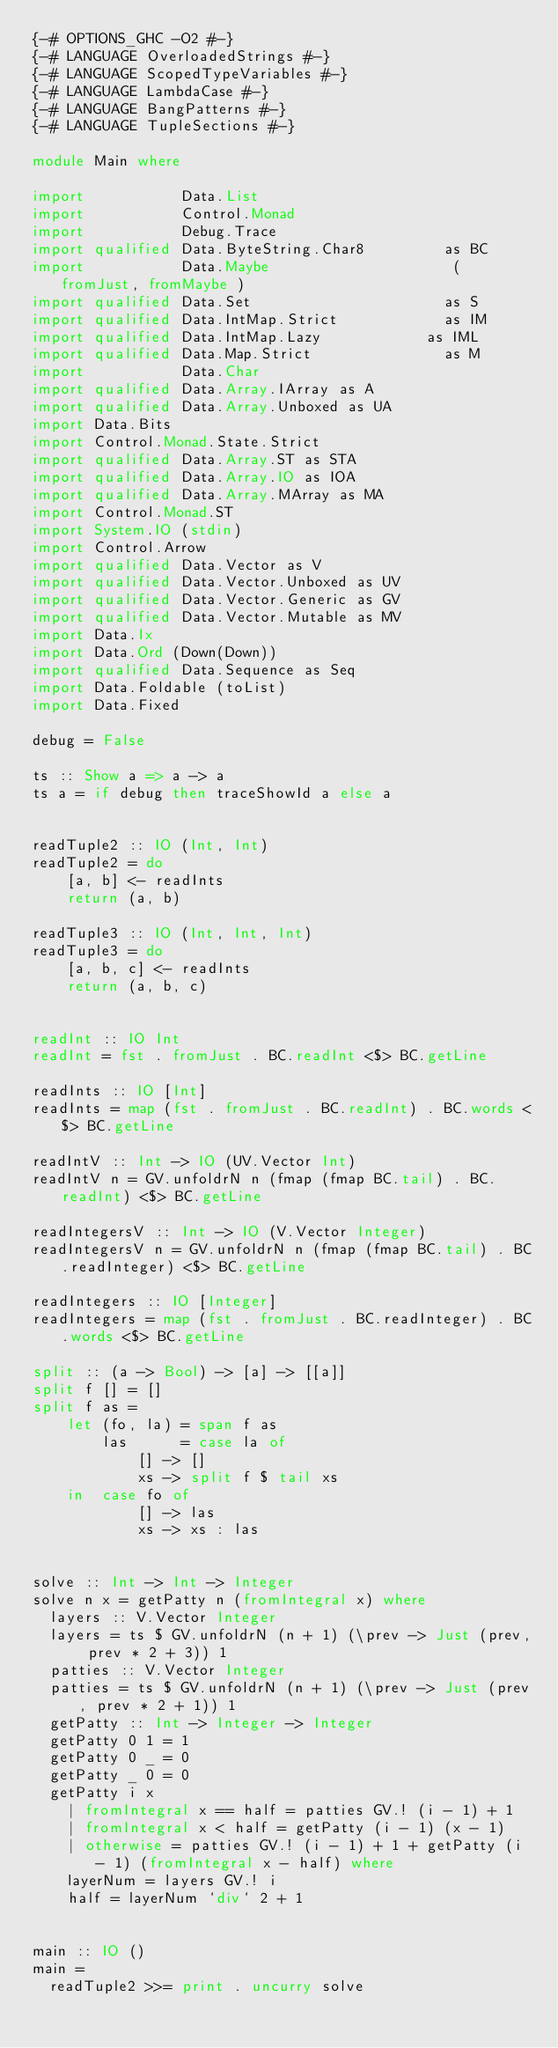Convert code to text. <code><loc_0><loc_0><loc_500><loc_500><_Haskell_>{-# OPTIONS_GHC -O2 #-}
{-# LANGUAGE OverloadedStrings #-}
{-# LANGUAGE ScopedTypeVariables #-}
{-# LANGUAGE LambdaCase #-}
{-# LANGUAGE BangPatterns #-}
{-# LANGUAGE TupleSections #-}

module Main where

import           Data.List
import           Control.Monad
import           Debug.Trace
import qualified Data.ByteString.Char8         as BC
import           Data.Maybe                     ( fromJust, fromMaybe )
import qualified Data.Set                      as S
import qualified Data.IntMap.Strict            as IM
import qualified Data.IntMap.Lazy            as IML
import qualified Data.Map.Strict               as M
import           Data.Char
import qualified Data.Array.IArray as A
import qualified Data.Array.Unboxed as UA
import Data.Bits
import Control.Monad.State.Strict
import qualified Data.Array.ST as STA
import qualified Data.Array.IO as IOA
import qualified Data.Array.MArray as MA
import Control.Monad.ST
import System.IO (stdin)
import Control.Arrow
import qualified Data.Vector as V
import qualified Data.Vector.Unboxed as UV
import qualified Data.Vector.Generic as GV
import qualified Data.Vector.Mutable as MV
import Data.Ix
import Data.Ord (Down(Down))
import qualified Data.Sequence as Seq
import Data.Foldable (toList)
import Data.Fixed

debug = False

ts :: Show a => a -> a
ts a = if debug then traceShowId a else a


readTuple2 :: IO (Int, Int)
readTuple2 = do
    [a, b] <- readInts
    return (a, b)

readTuple3 :: IO (Int, Int, Int)
readTuple3 = do
    [a, b, c] <- readInts
    return (a, b, c)


readInt :: IO Int
readInt = fst . fromJust . BC.readInt <$> BC.getLine

readInts :: IO [Int]
readInts = map (fst . fromJust . BC.readInt) . BC.words <$> BC.getLine

readIntV :: Int -> IO (UV.Vector Int)
readIntV n = GV.unfoldrN n (fmap (fmap BC.tail) . BC.readInt) <$> BC.getLine

readIntegersV :: Int -> IO (V.Vector Integer)
readIntegersV n = GV.unfoldrN n (fmap (fmap BC.tail) . BC.readInteger) <$> BC.getLine

readIntegers :: IO [Integer]
readIntegers = map (fst . fromJust . BC.readInteger) . BC.words <$> BC.getLine

split :: (a -> Bool) -> [a] -> [[a]]
split f [] = []
split f as =
    let (fo, la) = span f as
        las      = case la of
            [] -> []
            xs -> split f $ tail xs
    in  case fo of
            [] -> las
            xs -> xs : las


solve :: Int -> Int -> Integer
solve n x = getPatty n (fromIntegral x) where
  layers :: V.Vector Integer
  layers = ts $ GV.unfoldrN (n + 1) (\prev -> Just (prev, prev * 2 + 3)) 1
  patties :: V.Vector Integer
  patties = ts $ GV.unfoldrN (n + 1) (\prev -> Just (prev, prev * 2 + 1)) 1
  getPatty :: Int -> Integer -> Integer
  getPatty 0 1 = 1
  getPatty 0 _ = 0
  getPatty _ 0 = 0
  getPatty i x
    | fromIntegral x == half = patties GV.! (i - 1) + 1
    | fromIntegral x < half = getPatty (i - 1) (x - 1)
    | otherwise = patties GV.! (i - 1) + 1 + getPatty (i - 1) (fromIntegral x - half) where
    layerNum = layers GV.! i
    half = layerNum `div` 2 + 1


main :: IO ()
main =
  readTuple2 >>= print . uncurry solve
</code> 